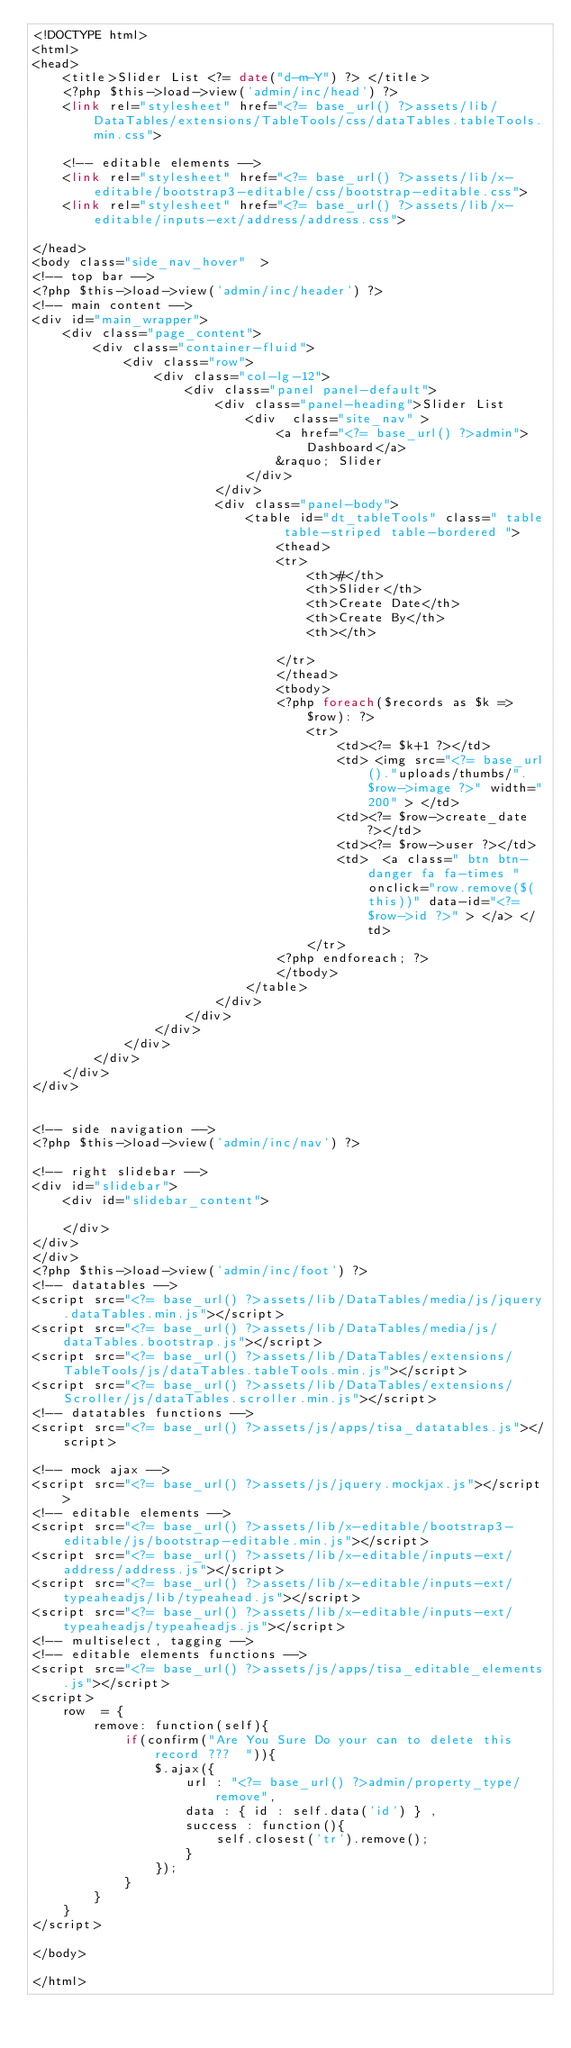<code> <loc_0><loc_0><loc_500><loc_500><_PHP_><!DOCTYPE html>
<html>
<head>
    <title>Slider List <?= date("d-m-Y") ?> </title>
    <?php $this->load->view('admin/inc/head') ?>
    <link rel="stylesheet" href="<?= base_url() ?>assets/lib/DataTables/extensions/TableTools/css/dataTables.tableTools.min.css">

    <!-- editable elements -->
    <link rel="stylesheet" href="<?= base_url() ?>assets/lib/x-editable/bootstrap3-editable/css/bootstrap-editable.css">
    <link rel="stylesheet" href="<?= base_url() ?>assets/lib/x-editable/inputs-ext/address/address.css">

</head>
<body class="side_nav_hover"  >
<!-- top bar -->
<?php $this->load->view('admin/inc/header') ?>
<!-- main content -->
<div id="main_wrapper">
    <div class="page_content">
        <div class="container-fluid">
            <div class="row">
                <div class="col-lg-12">
                    <div class="panel panel-default">
                        <div class="panel-heading">Slider List
                            <div  class="site_nav" >
                                <a href="<?= base_url() ?>admin">Dashboard</a>
                                &raquo; Slider
                            </div>
                        </div>
                        <div class="panel-body">
                            <table id="dt_tableTools" class=" table table-striped table-bordered ">
                                <thead>
                                <tr>
                                    <th>#</th>
                                    <th>Slider</th>
                                    <th>Create Date</th>
                                    <th>Create By</th>
                                    <th></th>

                                </tr>
                                </thead>
                                <tbody>
                                <?php foreach($records as $k => $row): ?>
                                    <tr>
                                        <td><?= $k+1 ?></td>
                                        <td> <img src="<?= base_url()."uploads/thumbs/".$row->image ?>" width="200" > </td>
                                        <td><?= $row->create_date ?></td>
                                        <td><?= $row->user ?></td>
                                        <td>  <a class=" btn btn-danger fa fa-times " onclick="row.remove($(this))" data-id="<?= $row->id ?>" > </a> </td>
                                    </tr>
                                <?php endforeach; ?>
                                </tbody>
                            </table>
                        </div>
                    </div>
                </div>
            </div>
        </div>
    </div>
</div>


<!-- side navigation -->
<?php $this->load->view('admin/inc/nav') ?>

<!-- right slidebar -->
<div id="slidebar">
    <div id="slidebar_content">

    </div>
</div>
</div>
<?php $this->load->view('admin/inc/foot') ?>
<!-- datatables -->
<script src="<?= base_url() ?>assets/lib/DataTables/media/js/jquery.dataTables.min.js"></script>
<script src="<?= base_url() ?>assets/lib/DataTables/media/js/dataTables.bootstrap.js"></script>
<script src="<?= base_url() ?>assets/lib/DataTables/extensions/TableTools/js/dataTables.tableTools.min.js"></script>
<script src="<?= base_url() ?>assets/lib/DataTables/extensions/Scroller/js/dataTables.scroller.min.js"></script>
<!-- datatables functions -->
<script src="<?= base_url() ?>assets/js/apps/tisa_datatables.js"></script>

<!-- mock ajax -->
<script src="<?= base_url() ?>assets/js/jquery.mockjax.js"></script>
<!-- editable elements -->
<script src="<?= base_url() ?>assets/lib/x-editable/bootstrap3-editable/js/bootstrap-editable.min.js"></script>
<script src="<?= base_url() ?>assets/lib/x-editable/inputs-ext/address/address.js"></script>
<script src="<?= base_url() ?>assets/lib/x-editable/inputs-ext/typeaheadjs/lib/typeahead.js"></script>
<script src="<?= base_url() ?>assets/lib/x-editable/inputs-ext/typeaheadjs/typeaheadjs.js"></script>
<!-- multiselect, tagging -->
<!-- editable elements functions -->
<script src="<?= base_url() ?>assets/js/apps/tisa_editable_elements.js"></script>
<script>
    row  = {
        remove: function(self){
            if(confirm("Are You Sure Do your can to delete this record ???  ")){
                $.ajax({
                    url : "<?= base_url() ?>admin/property_type/remove",
                    data : { id : self.data('id') } ,
                    success : function(){
                        self.closest('tr').remove();
                    }
                });
            }
        }
    }
</script>

</body>

</html></code> 